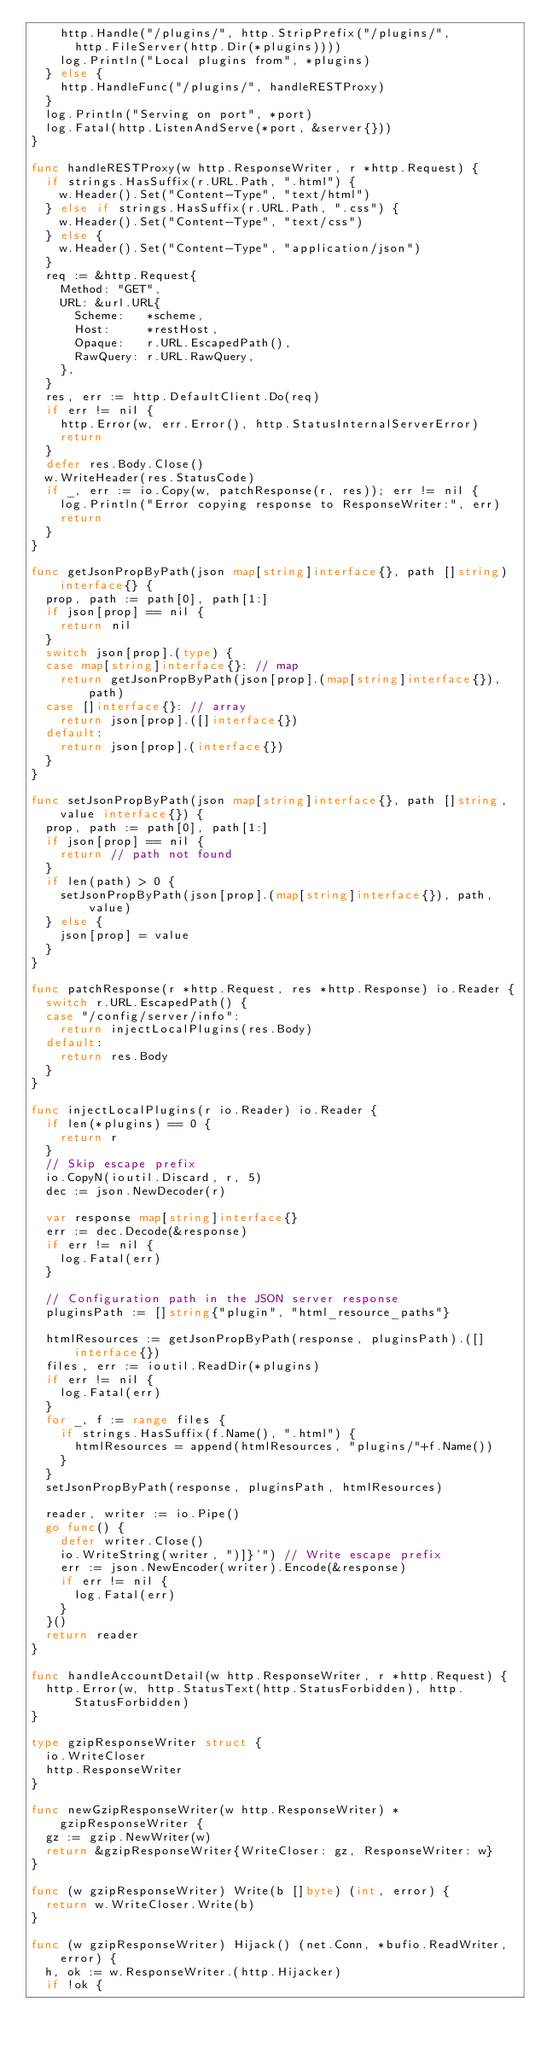Convert code to text. <code><loc_0><loc_0><loc_500><loc_500><_Go_>		http.Handle("/plugins/", http.StripPrefix("/plugins/",
			http.FileServer(http.Dir(*plugins))))
		log.Println("Local plugins from", *plugins)
	} else {
		http.HandleFunc("/plugins/", handleRESTProxy)
	}
	log.Println("Serving on port", *port)
	log.Fatal(http.ListenAndServe(*port, &server{}))
}

func handleRESTProxy(w http.ResponseWriter, r *http.Request) {
	if strings.HasSuffix(r.URL.Path, ".html") {
		w.Header().Set("Content-Type", "text/html")
	} else if strings.HasSuffix(r.URL.Path, ".css") {
		w.Header().Set("Content-Type", "text/css")
	} else {
		w.Header().Set("Content-Type", "application/json")
	}
	req := &http.Request{
		Method: "GET",
		URL: &url.URL{
			Scheme:   *scheme,
			Host:     *restHost,
			Opaque:   r.URL.EscapedPath(),
			RawQuery: r.URL.RawQuery,
		},
	}
	res, err := http.DefaultClient.Do(req)
	if err != nil {
		http.Error(w, err.Error(), http.StatusInternalServerError)
		return
	}
	defer res.Body.Close()
	w.WriteHeader(res.StatusCode)
	if _, err := io.Copy(w, patchResponse(r, res)); err != nil {
		log.Println("Error copying response to ResponseWriter:", err)
		return
	}
}

func getJsonPropByPath(json map[string]interface{}, path []string) interface{} {
	prop, path := path[0], path[1:]
	if json[prop] == nil {
		return nil
	}
	switch json[prop].(type) {
	case map[string]interface{}: // map
		return getJsonPropByPath(json[prop].(map[string]interface{}), path)
	case []interface{}: // array
		return json[prop].([]interface{})
	default:
		return json[prop].(interface{})
	}
}

func setJsonPropByPath(json map[string]interface{}, path []string, value interface{}) {
	prop, path := path[0], path[1:]
	if json[prop] == nil {
		return // path not found
	}
	if len(path) > 0 {
		setJsonPropByPath(json[prop].(map[string]interface{}), path, value)
	} else {
		json[prop] = value
	}
}

func patchResponse(r *http.Request, res *http.Response) io.Reader {
	switch r.URL.EscapedPath() {
	case "/config/server/info":
		return injectLocalPlugins(res.Body)
	default:
		return res.Body
	}
}

func injectLocalPlugins(r io.Reader) io.Reader {
	if len(*plugins) == 0 {
		return r
	}
	// Skip escape prefix
	io.CopyN(ioutil.Discard, r, 5)
	dec := json.NewDecoder(r)

	var response map[string]interface{}
	err := dec.Decode(&response)
	if err != nil {
		log.Fatal(err)
	}

	// Configuration path in the JSON server response
	pluginsPath := []string{"plugin", "html_resource_paths"}

	htmlResources := getJsonPropByPath(response, pluginsPath).([]interface{})
	files, err := ioutil.ReadDir(*plugins)
	if err != nil {
		log.Fatal(err)
	}
	for _, f := range files {
		if strings.HasSuffix(f.Name(), ".html") {
			htmlResources = append(htmlResources, "plugins/"+f.Name())
		}
	}
	setJsonPropByPath(response, pluginsPath, htmlResources)

	reader, writer := io.Pipe()
	go func() {
		defer writer.Close()
		io.WriteString(writer, ")]}'") // Write escape prefix
		err := json.NewEncoder(writer).Encode(&response)
		if err != nil {
			log.Fatal(err)
		}
	}()
	return reader
}

func handleAccountDetail(w http.ResponseWriter, r *http.Request) {
	http.Error(w, http.StatusText(http.StatusForbidden), http.StatusForbidden)
}

type gzipResponseWriter struct {
	io.WriteCloser
	http.ResponseWriter
}

func newGzipResponseWriter(w http.ResponseWriter) *gzipResponseWriter {
	gz := gzip.NewWriter(w)
	return &gzipResponseWriter{WriteCloser: gz, ResponseWriter: w}
}

func (w gzipResponseWriter) Write(b []byte) (int, error) {
	return w.WriteCloser.Write(b)
}

func (w gzipResponseWriter) Hijack() (net.Conn, *bufio.ReadWriter, error) {
	h, ok := w.ResponseWriter.(http.Hijacker)
	if !ok {</code> 